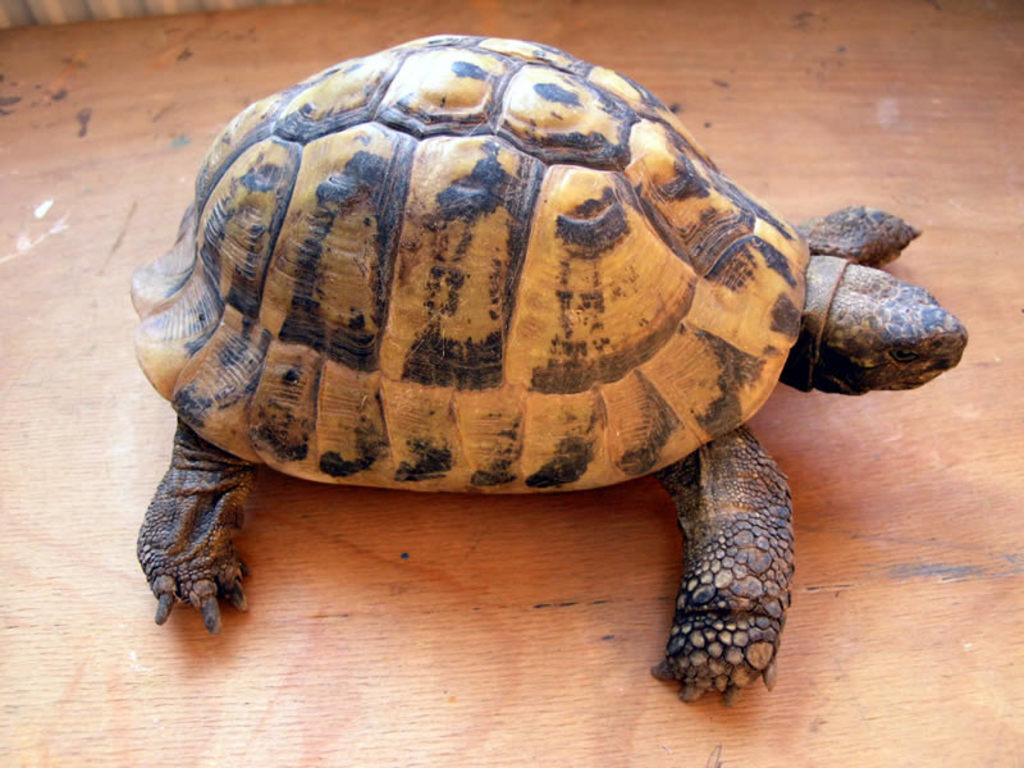What material is the plank in the image made of? The wooden plank in the image is made of wood. What animal is on the wooden plank? A tortoise is present on the wooden plank. What type of shade is provided by the tortoise on the wooden plank? There is no shade provided by the tortoise on the wooden plank, as it is an animal and not a source of shade. 